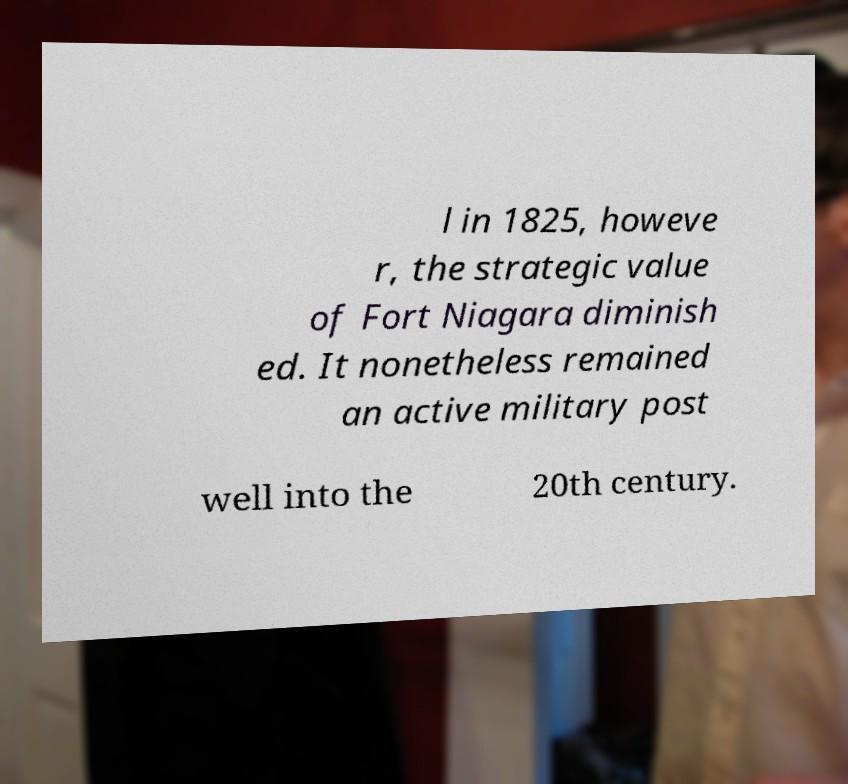Can you read and provide the text displayed in the image?This photo seems to have some interesting text. Can you extract and type it out for me? l in 1825, howeve r, the strategic value of Fort Niagara diminish ed. It nonetheless remained an active military post well into the 20th century. 